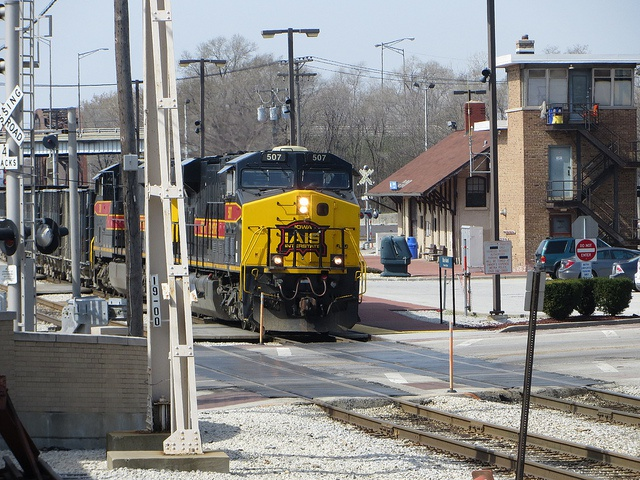Describe the objects in this image and their specific colors. I can see train in lavender, black, gray, gold, and olive tones, car in lavender, navy, darkblue, gray, and black tones, car in lavender, black, blue, darkblue, and gray tones, traffic light in lavender, black, gray, and darkblue tones, and traffic light in lavender, black, darkblue, and gray tones in this image. 